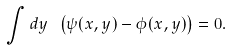<formula> <loc_0><loc_0><loc_500><loc_500>\int d y \ \left ( \psi ( x , y ) - \phi ( x , y ) \right ) = 0 .</formula> 